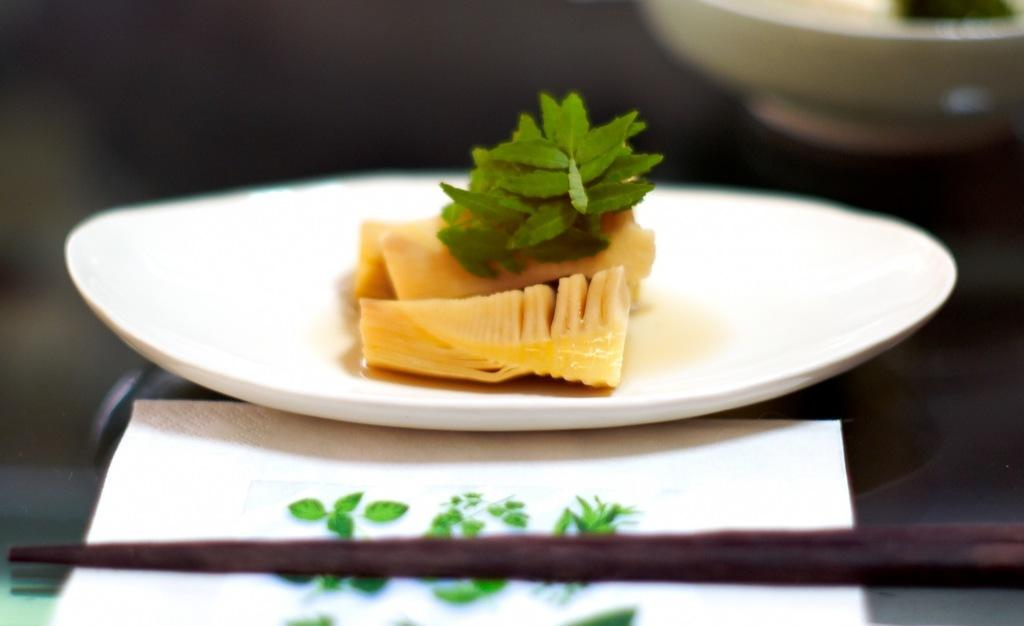What is in the bowl that is visible in the image? There is a bowl containing food in the image. What is on the plate that is visible in the image? There is a plate containing food in the image. Where are the bowl and plate located in the image? The bowl and plate are placed on a surface in the image. What is present in the foreground of the image? There is a tissue in the foreground of the image. What type of cloud can be seen in the image? There is no cloud present in the image; it features a bowl and plate containing food, as well as a tissue in the foreground. 